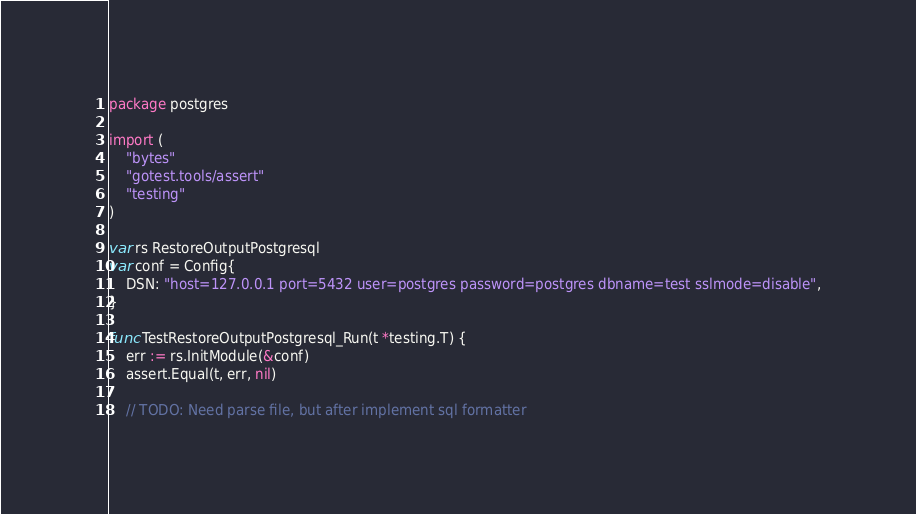Convert code to text. <code><loc_0><loc_0><loc_500><loc_500><_Go_>package postgres

import (
	"bytes"
	"gotest.tools/assert"
	"testing"
)

var rs RestoreOutputPostgresql
var conf = Config{
	DSN: "host=127.0.0.1 port=5432 user=postgres password=postgres dbname=test sslmode=disable",
}

func TestRestoreOutputPostgresql_Run(t *testing.T) {
	err := rs.InitModule(&conf)
	assert.Equal(t, err, nil)

	// TODO: Need parse file, but after implement sql formatter</code> 